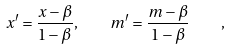Convert formula to latex. <formula><loc_0><loc_0><loc_500><loc_500>x ^ { \prime } = \frac { x - \beta } { 1 - \beta } , \quad m ^ { \prime } = \frac { m - \beta } { 1 - \beta } \quad ,</formula> 